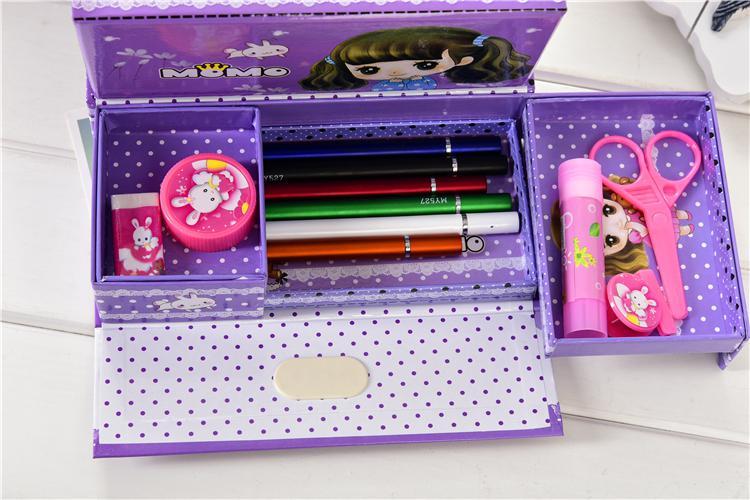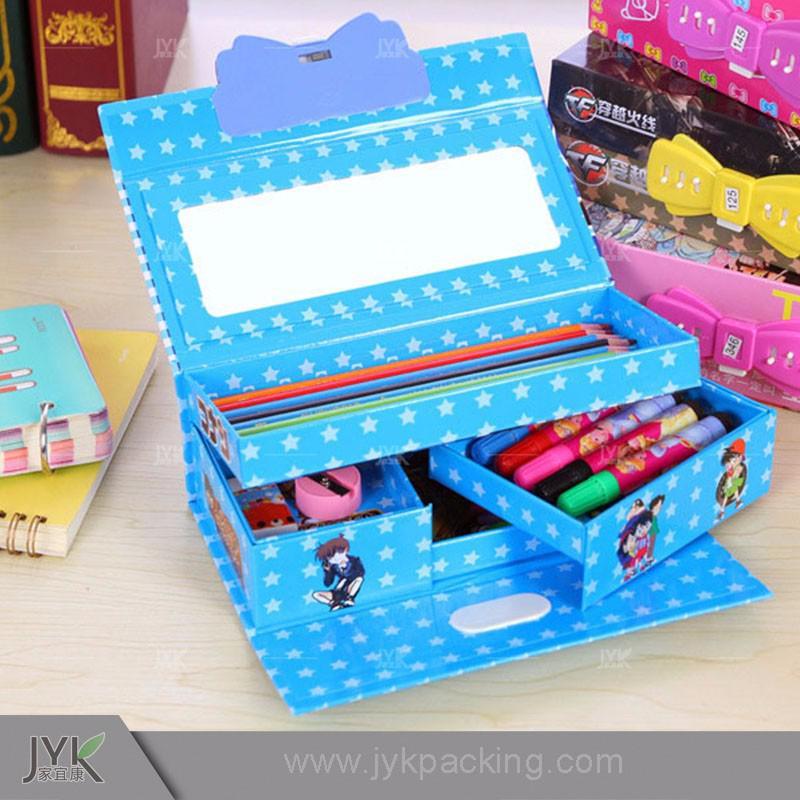The first image is the image on the left, the second image is the image on the right. Evaluate the accuracy of this statement regarding the images: "The right image contains a pencil holder that has a small drawer in the middle that is pulled out.". Is it true? Answer yes or no. Yes. The first image is the image on the left, the second image is the image on the right. For the images displayed, is the sentence "Both of the cases is opened to reveal their items." factually correct? Answer yes or no. Yes. 